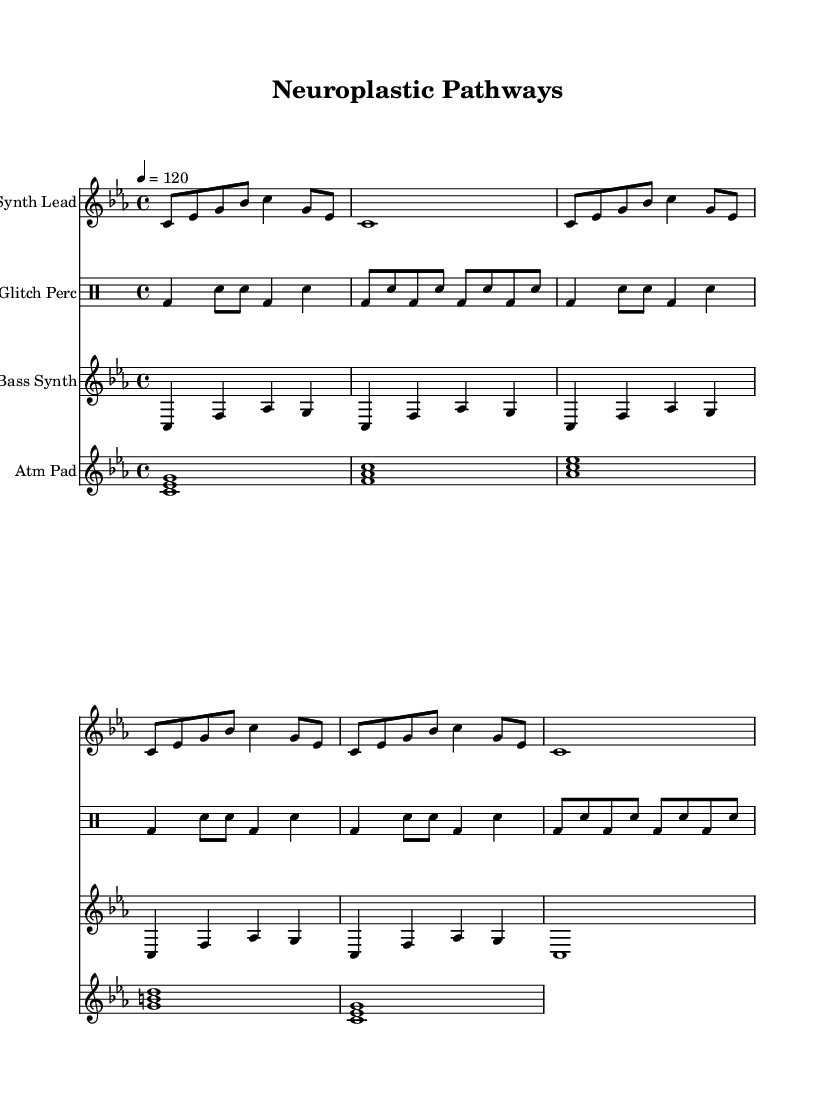What is the key signature of this music? The key signature is C minor, which is indicated by three flats on the staff.
Answer: C minor What is the time signature of the piece? The time signature is 4/4, which is shown at the beginning of the score. This means there are four beats in each measure.
Answer: 4/4 What is the tempo marking for the piece? The tempo marking indicates a speed of 120 beats per minute, which is shown as "4 = 120."
Answer: 120 How many measures are there in the synthesizer lead part? The synthesizer lead part consists of 7 measures, counting the repeated sections and the final whole note.
Answer: 7 What is the role of the Atm Pad in this piece? The Atm Pad provides harmonic support with sustained chords, played as one whole note per measure, creating a lush background texture.
Answer: Harmonic support How does the glitch percussion contribute to the overall sound? The glitch percussion adds rhythmic variety and texture, featuring unconventional sounds that complement the synthetic elements and enhance the track’s glitch style.
Answer: Rhythmic variety What type of electronic music is being represented in this score? The music represents glitch-influenced electronic, characterized by interruptions, unexpected sonic elements, and experimental sounds.
Answer: Glitch-influenced electronic 